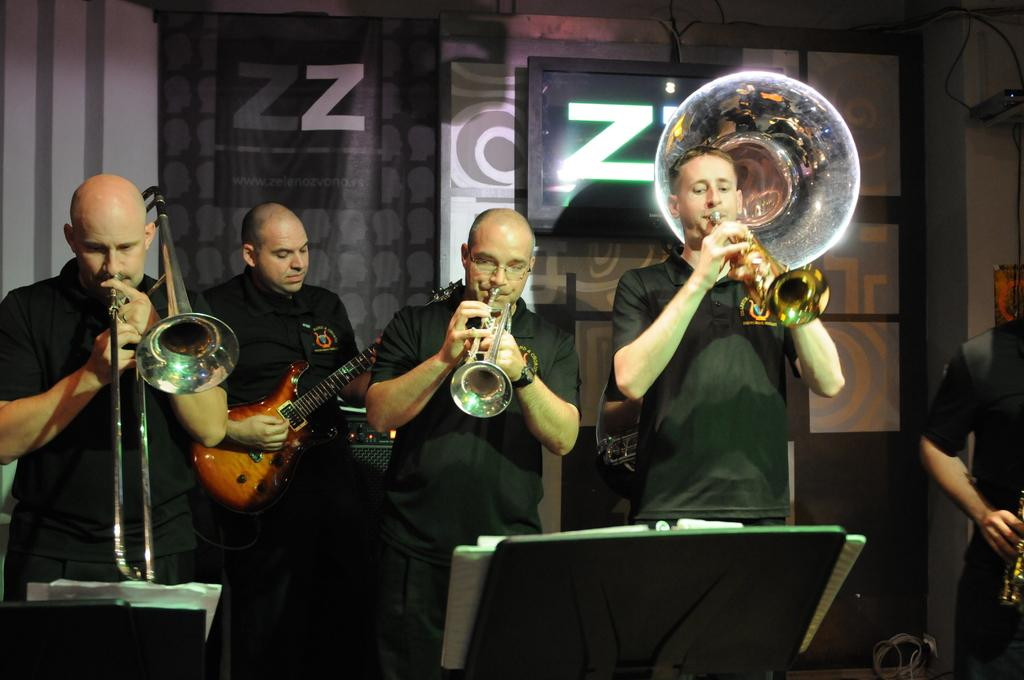How many people are in the image? There are five members in the image. What are the members doing in the image? Each member is playing a different musical instrument. Reasoning: Let's think step by step by step in order to produce the conversation. We start by identifying the number of people in the image, which is five. Then, we describe what they are doing, which is playing different musical instruments. Each question is designed to elicit a specific detail about the image that is known from the provided facts. Absurd Question/Answer: What type of bell can be heard ringing in the image? There is no bell present in the image, and therefore no sound can be heard. What type of card is being played by the members in the image? There is no card game present in the image; the members are playing musical instruments. --- Facts: 1. There is a person sitting on a chair in the image. 2. The person is holding a book. 3. The book has a blue cover. 4. There is a table next to the chair. 5. The table has a lamp on it. Absurd Topics: parrot, bicycle, ocean Conversation: What is the person in the image doing? The person is sitting on a chair in the image. What is the person holding in the image? The person is holding a book in the image. What color is the book's cover? The book has a blue cover. What is on the table next to the chair? There is a lamp on the table next to the chair. Reasoning: Let's think step by step in order to produce the conversation. We start by identifying the main subject in the image, which is the person sitting on a chair. Then, we expand the conversation to include other items that are also visible, such as the book, its blue cover, the table, and the lamp. Each question is designed to elicit a specific detail about the image that is known from the provided facts. Absurd Question/Answer: 